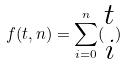<formula> <loc_0><loc_0><loc_500><loc_500>f ( t , n ) = \sum _ { i = 0 } ^ { n } ( \begin{matrix} t \\ i \end{matrix} )</formula> 